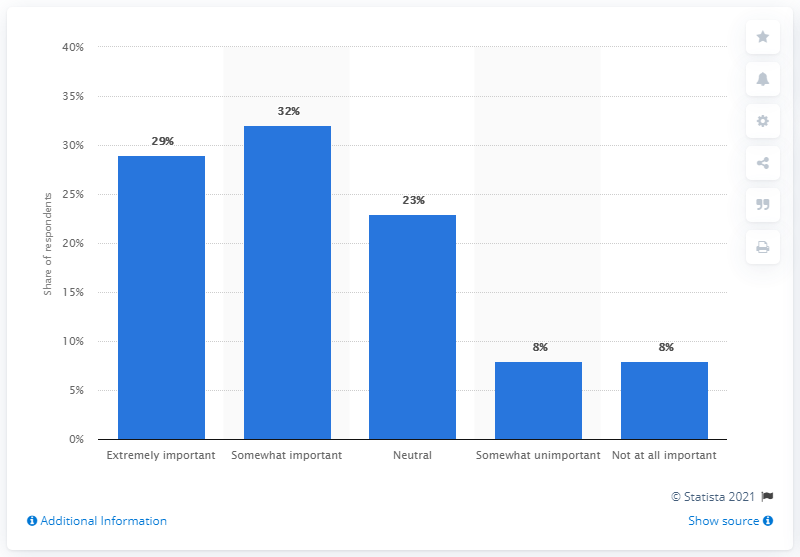Outline some significant characteristics in this image. According to the respondents, brand names were considered to be extremely important for their purchase decisions, with 29% of them stating this. 